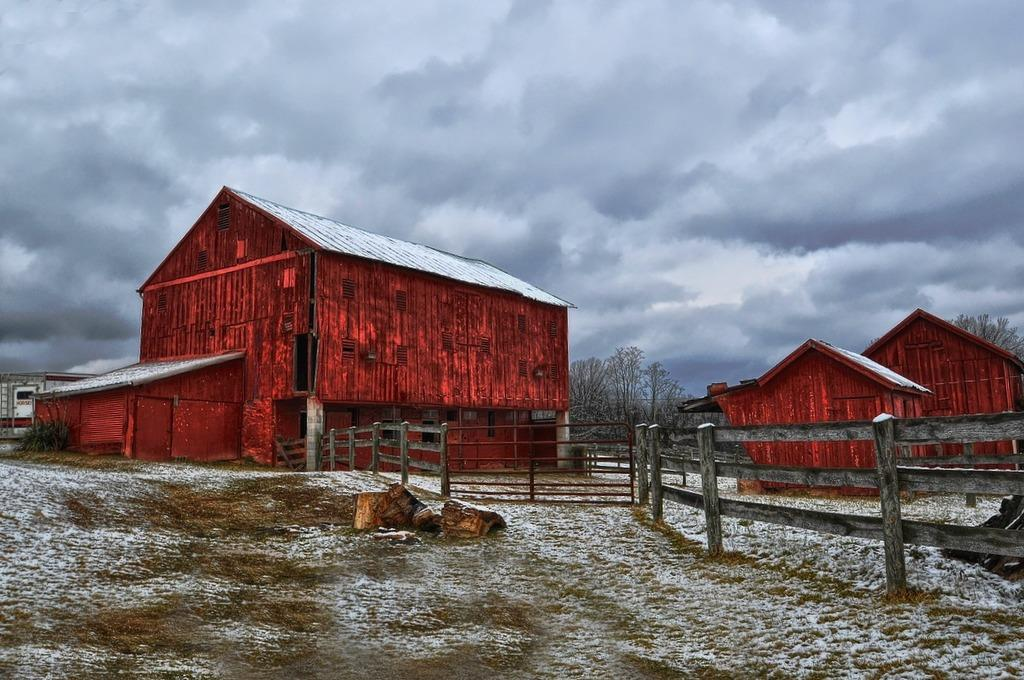What can be seen in the center of the picture? There are houses and trees in the center of the picture. What is located in the foreground of the image? Wooden logs, a railing, sand, and snow are present in the foreground. What is the condition of the sky in the sky? The sky is cloudy. How many planes can be seen carrying bags of oranges in the image? There are no planes or bags of oranges present in the image. What type of fruit is being harvested from the trees in the image? There is no fruit being harvested from the trees in the image; the trees are not the focus of the image. 